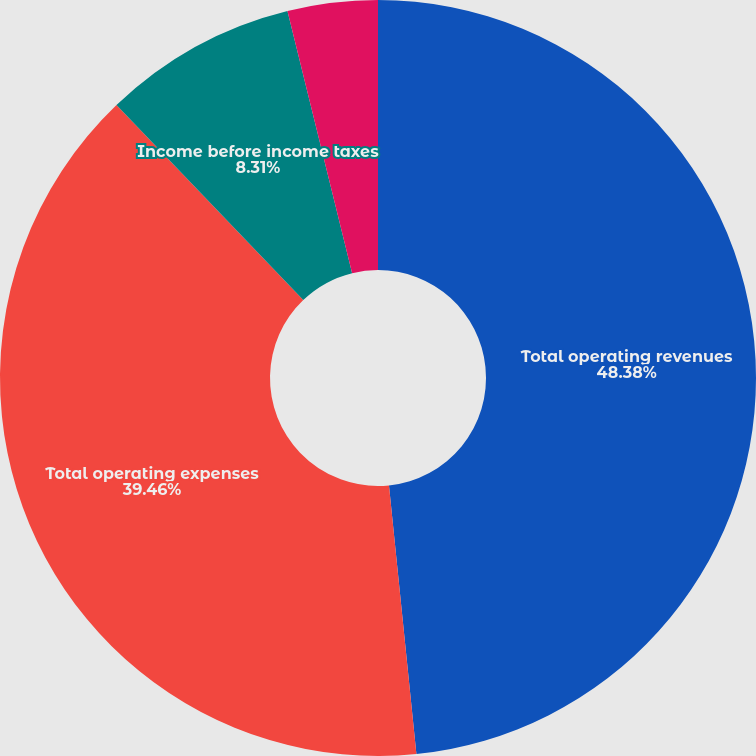Convert chart. <chart><loc_0><loc_0><loc_500><loc_500><pie_chart><fcel>Total operating revenues<fcel>Total operating expenses<fcel>Income before income taxes<fcel>Net income/(loss)<nl><fcel>48.38%<fcel>39.46%<fcel>8.31%<fcel>3.85%<nl></chart> 